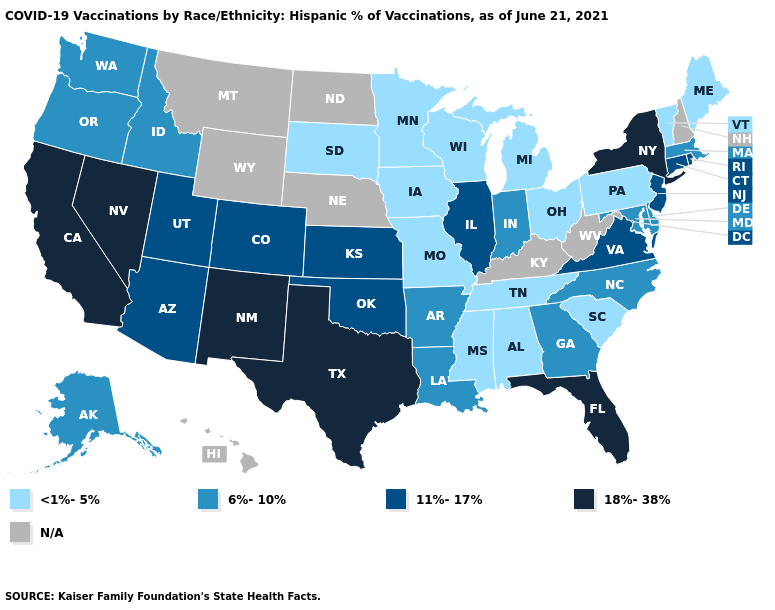Which states hav the highest value in the MidWest?
Keep it brief. Illinois, Kansas. Does Connecticut have the lowest value in the Northeast?
Short answer required. No. Name the states that have a value in the range N/A?
Answer briefly. Hawaii, Kentucky, Montana, Nebraska, New Hampshire, North Dakota, West Virginia, Wyoming. What is the value of Illinois?
Keep it brief. 11%-17%. Name the states that have a value in the range 18%-38%?
Quick response, please. California, Florida, Nevada, New Mexico, New York, Texas. What is the value of Nevada?
Concise answer only. 18%-38%. What is the lowest value in the USA?
Write a very short answer. <1%-5%. Does Utah have the highest value in the West?
Short answer required. No. Name the states that have a value in the range 18%-38%?
Short answer required. California, Florida, Nevada, New Mexico, New York, Texas. Which states have the lowest value in the USA?
Short answer required. Alabama, Iowa, Maine, Michigan, Minnesota, Mississippi, Missouri, Ohio, Pennsylvania, South Carolina, South Dakota, Tennessee, Vermont, Wisconsin. Name the states that have a value in the range 6%-10%?
Quick response, please. Alaska, Arkansas, Delaware, Georgia, Idaho, Indiana, Louisiana, Maryland, Massachusetts, North Carolina, Oregon, Washington. What is the value of Georgia?
Keep it brief. 6%-10%. What is the highest value in the USA?
Quick response, please. 18%-38%. Does the first symbol in the legend represent the smallest category?
Answer briefly. Yes. 